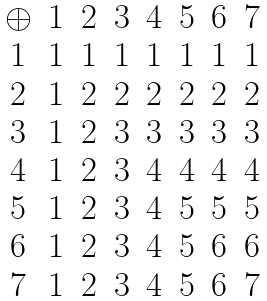Convert formula to latex. <formula><loc_0><loc_0><loc_500><loc_500>\begin{matrix} \oplus & { 1 } & { 2 } & { 3 } & { 4 } & { 5 } & { 6 } & { 7 } \\ { 1 } & 1 & 1 & 1 & 1 & 1 & 1 & 1 \\ { 2 } & 1 & 2 & 2 & 2 & 2 & 2 & 2 \\ { 3 } & 1 & 2 & 3 & 3 & 3 & 3 & 3 \\ { 4 } & 1 & 2 & 3 & 4 & 4 & 4 & 4 \\ { 5 } & 1 & 2 & 3 & 4 & 5 & 5 & 5 \\ { 6 } & 1 & 2 & 3 & 4 & 5 & 6 & 6 \\ { 7 } & 1 & 2 & 3 & 4 & 5 & 6 & 7 \\ \end{matrix}</formula> 